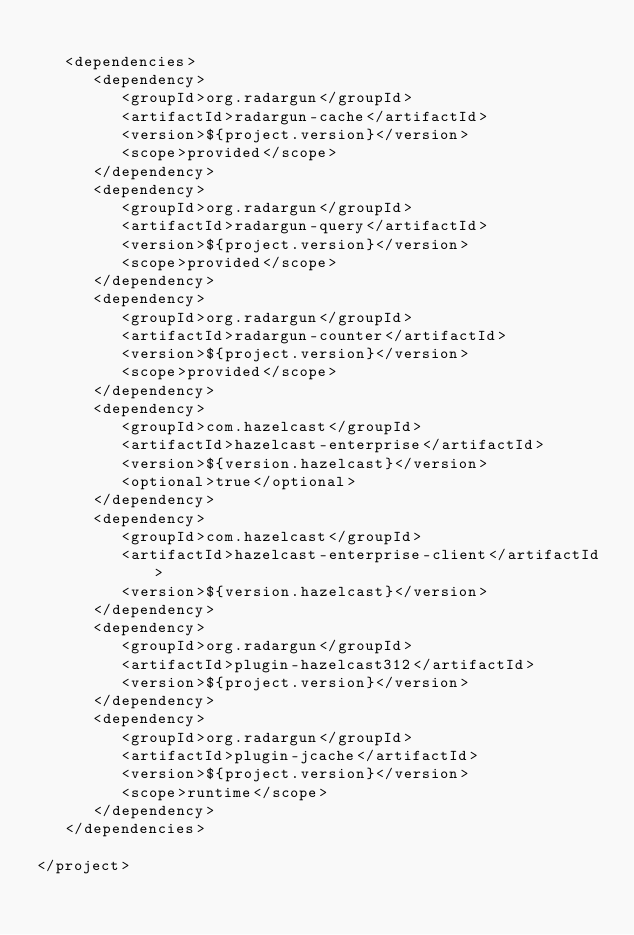<code> <loc_0><loc_0><loc_500><loc_500><_XML_>
   <dependencies>
      <dependency>
         <groupId>org.radargun</groupId>
         <artifactId>radargun-cache</artifactId>
         <version>${project.version}</version>
         <scope>provided</scope>
      </dependency>
      <dependency>
         <groupId>org.radargun</groupId>
         <artifactId>radargun-query</artifactId>
         <version>${project.version}</version>
         <scope>provided</scope>
      </dependency>
      <dependency>
         <groupId>org.radargun</groupId>
         <artifactId>radargun-counter</artifactId>
         <version>${project.version}</version>
         <scope>provided</scope>
      </dependency>
      <dependency>
         <groupId>com.hazelcast</groupId>
         <artifactId>hazelcast-enterprise</artifactId>
         <version>${version.hazelcast}</version>
         <optional>true</optional>
      </dependency>
      <dependency>
         <groupId>com.hazelcast</groupId>
         <artifactId>hazelcast-enterprise-client</artifactId>
         <version>${version.hazelcast}</version>
      </dependency>
      <dependency>
         <groupId>org.radargun</groupId>
         <artifactId>plugin-hazelcast312</artifactId>
         <version>${project.version}</version>
      </dependency>
      <dependency>
         <groupId>org.radargun</groupId>
         <artifactId>plugin-jcache</artifactId>
         <version>${project.version}</version>
         <scope>runtime</scope>
      </dependency>
   </dependencies>

</project>
</code> 